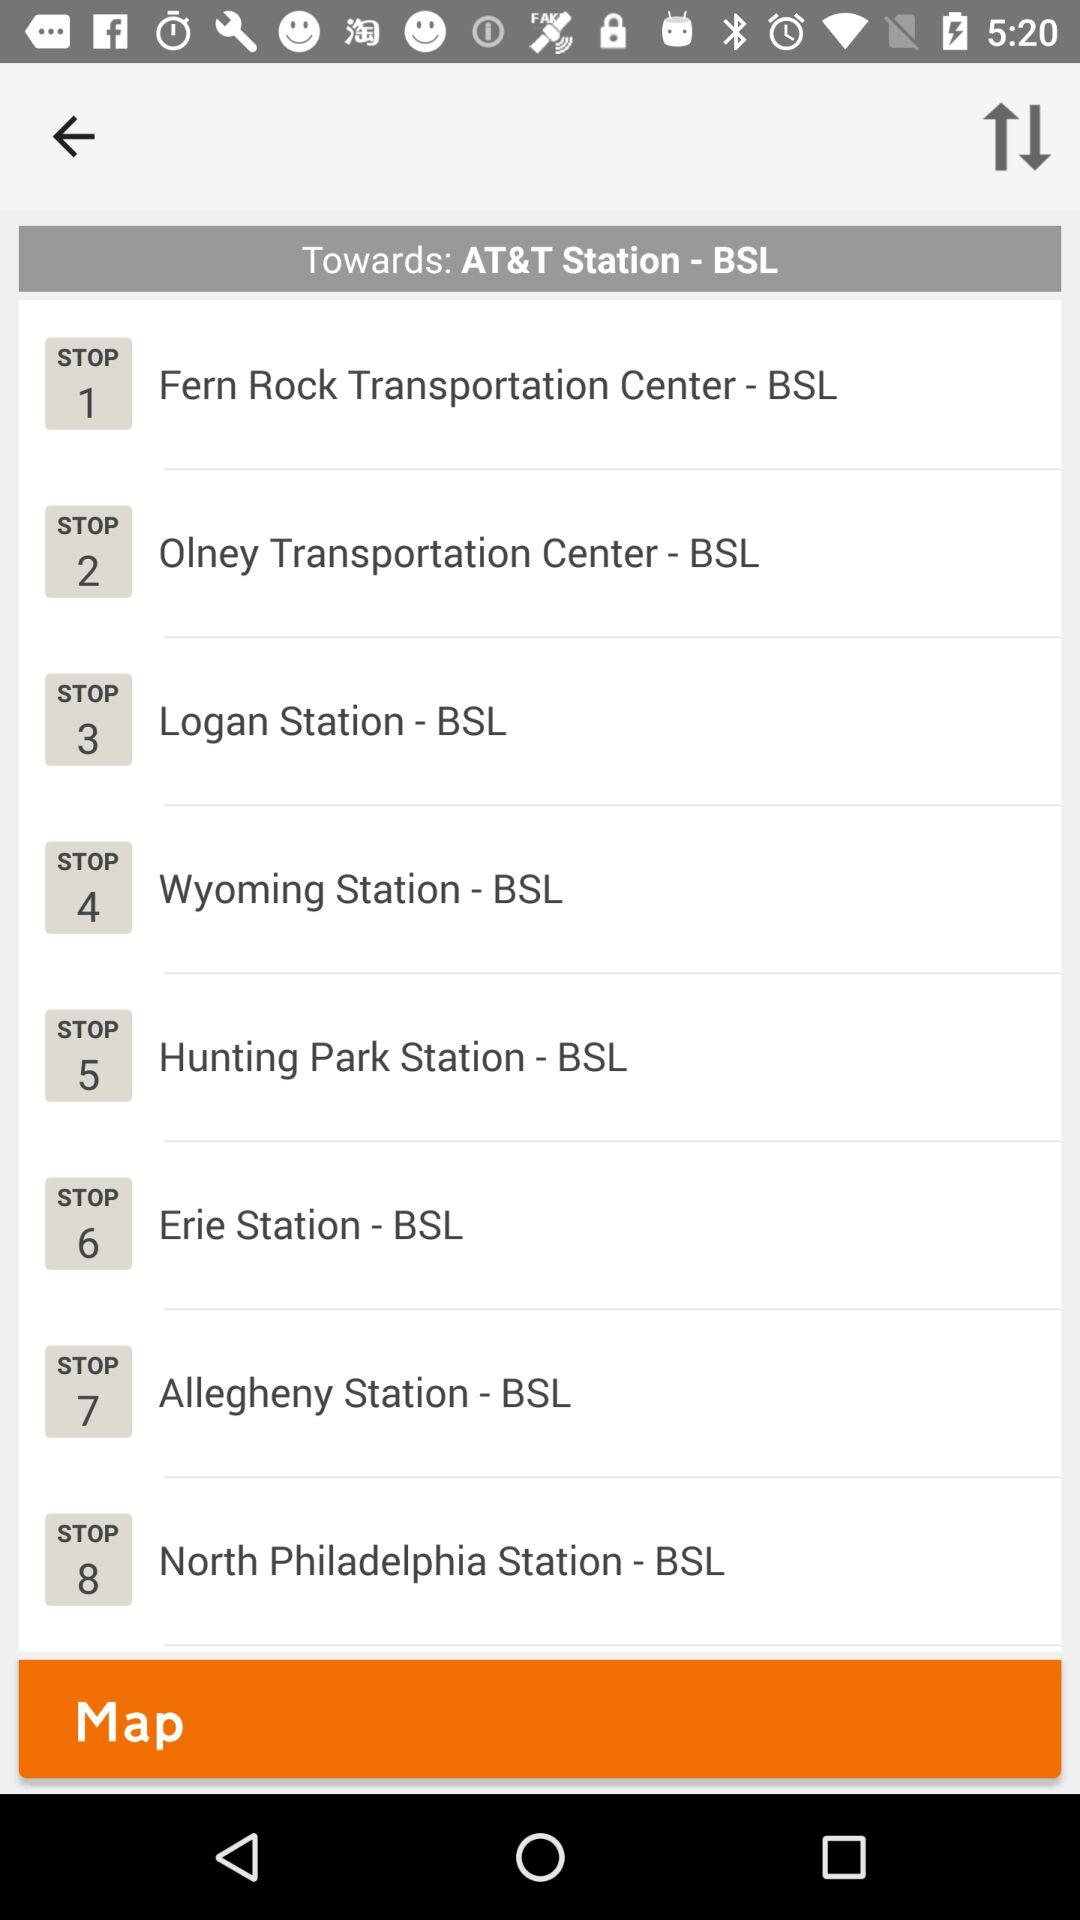How many stops are there in total?
When the provided information is insufficient, respond with <no answer>. <no answer> 